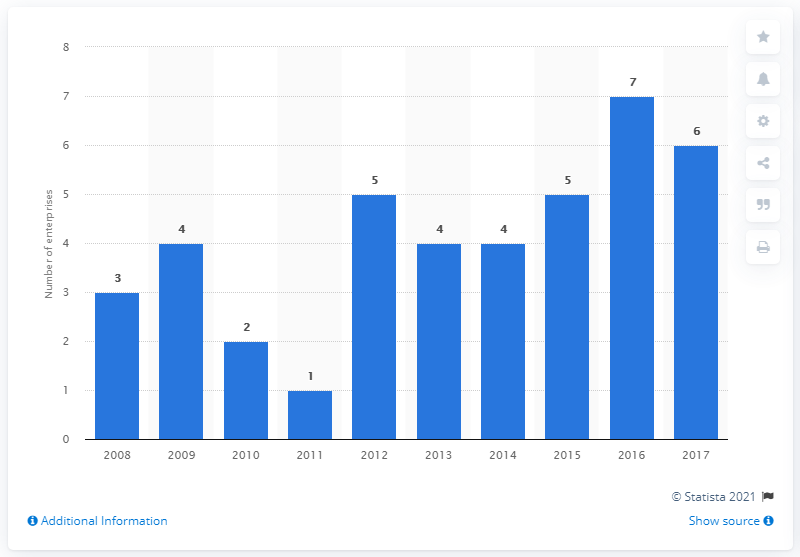Is there an overall trend in the number of employees over the years? Analyzing the histogram, there is an upward trend in the number of employees from 2008 to 2017, with some fluctuations. The number starts lower, sees an intermediate drop around 2011, then climbs with the highest point in 2017, indicating growth over the decade. 